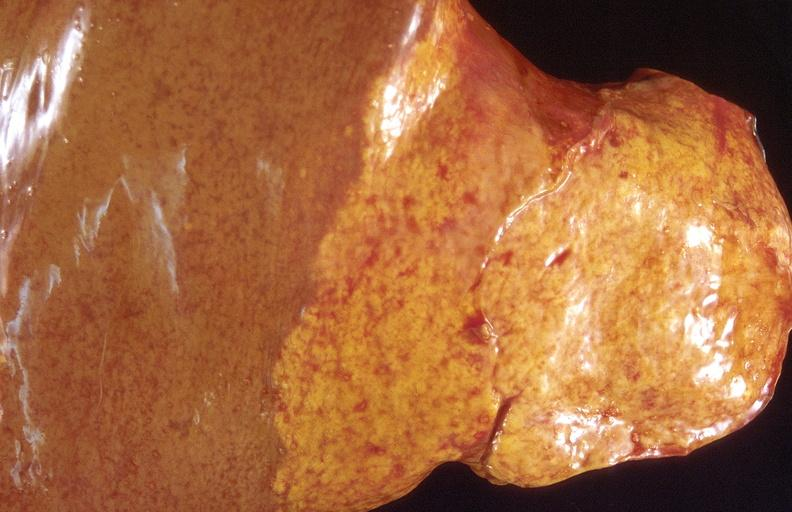does vasculitis foreign body show cholangiocarcinoma?
Answer the question using a single word or phrase. No 